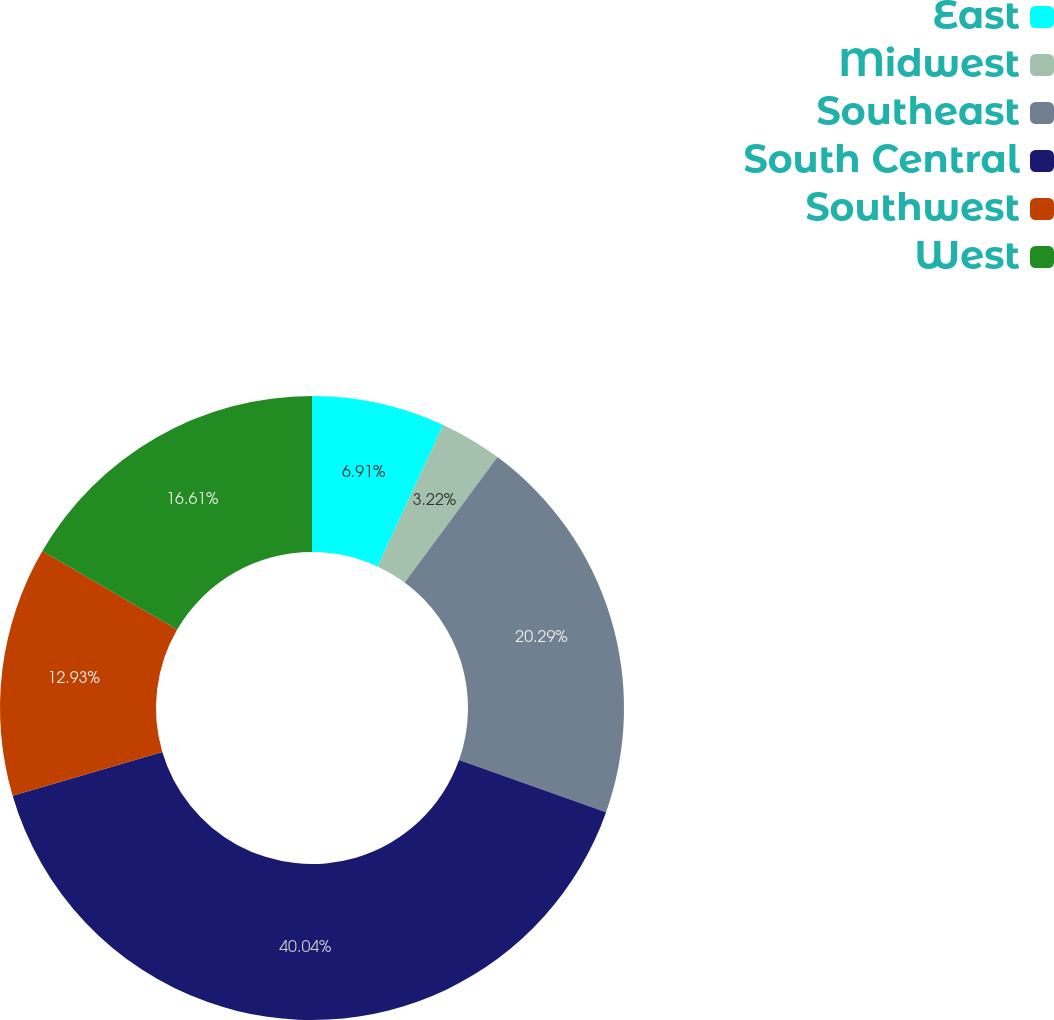Convert chart. <chart><loc_0><loc_0><loc_500><loc_500><pie_chart><fcel>East<fcel>Midwest<fcel>Southeast<fcel>South Central<fcel>Southwest<fcel>West<nl><fcel>6.91%<fcel>3.22%<fcel>20.29%<fcel>40.04%<fcel>12.93%<fcel>16.61%<nl></chart> 